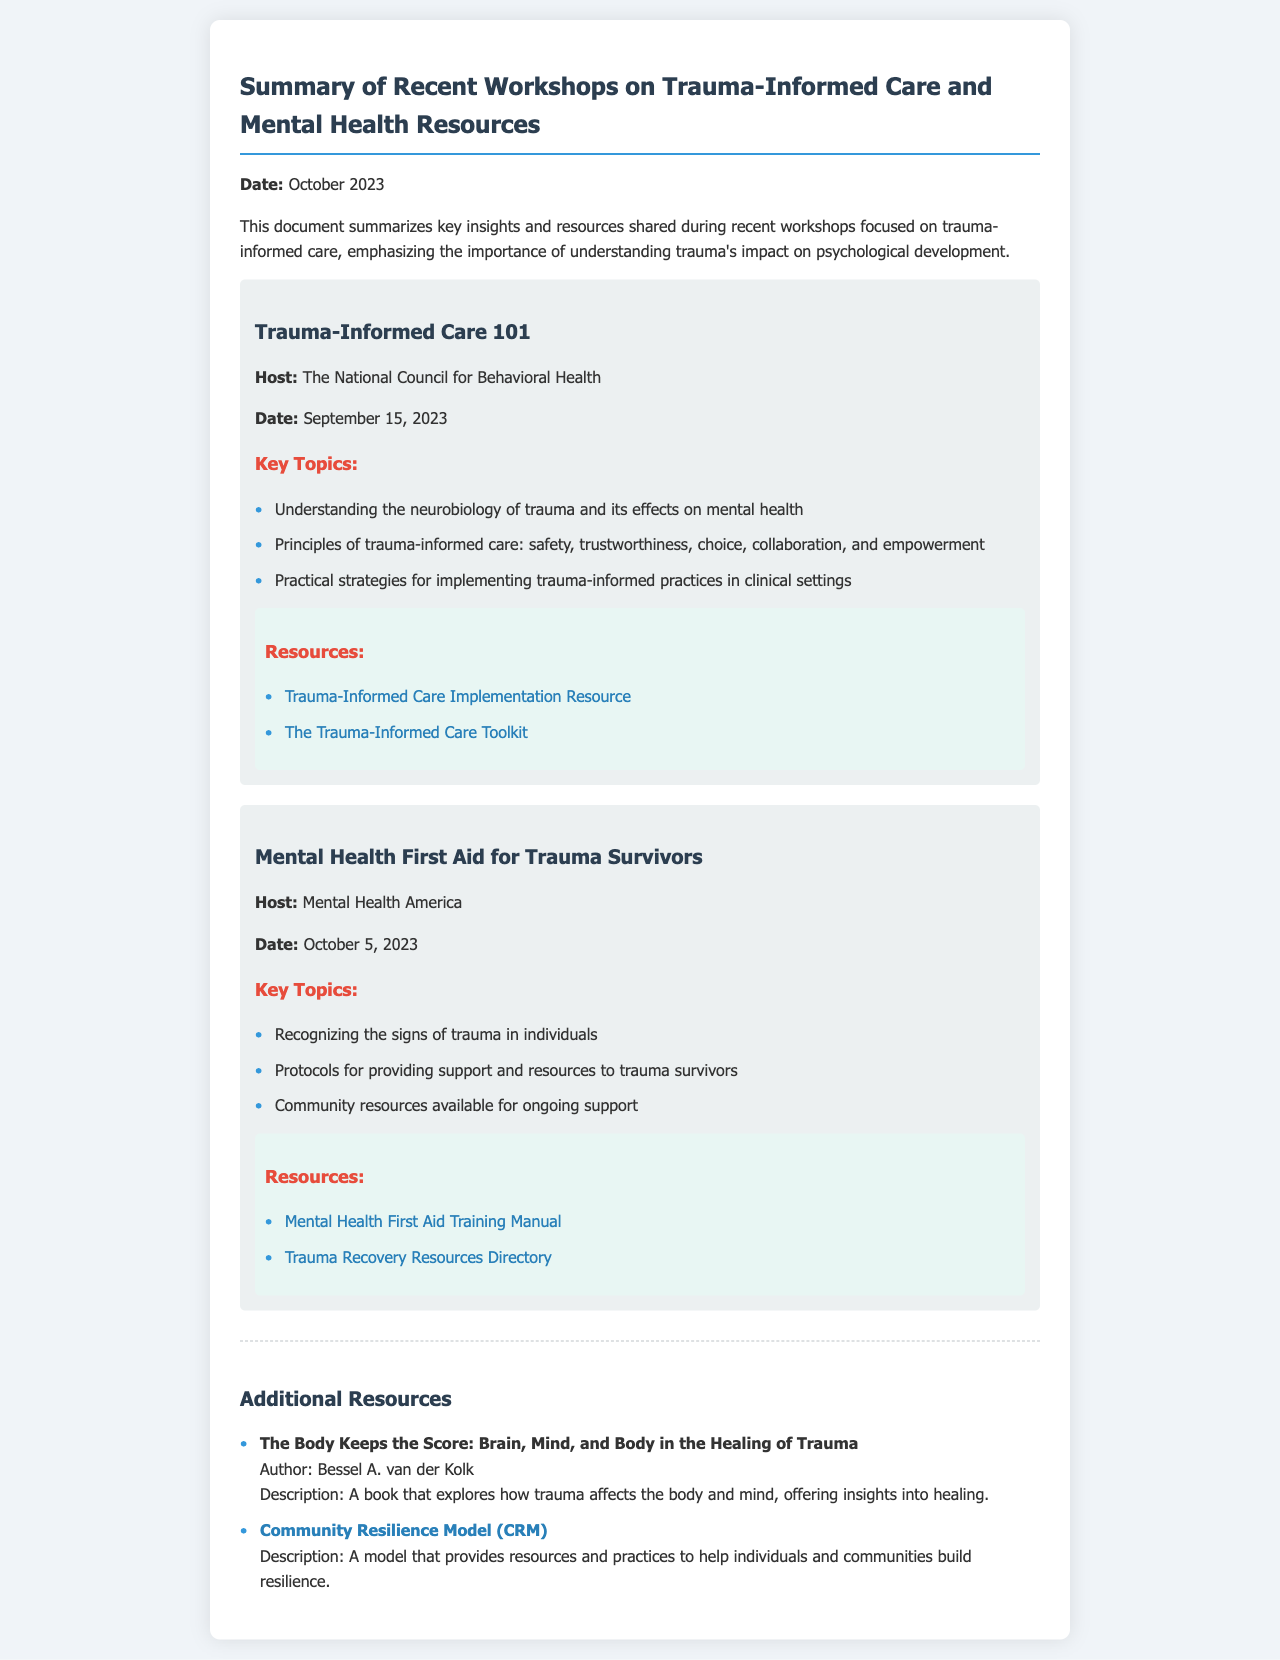What is the date of the document? The document mentions the date in the introductory paragraph as October 2023.
Answer: October 2023 Who hosted the workshop titled "Mental Health First Aid for Trauma Survivors"? The workshop title indicates that it was hosted by Mental Health America.
Answer: Mental Health America What is one key topic of the "Trauma-Informed Care 101" workshop? The document lists several key topics, one of which is understanding the neurobiology of trauma and its effects on mental health.
Answer: Understanding the neurobiology of trauma and its effects on mental health When did the "Trauma-Informed Care 101" workshop take place? The date of the workshop is provided in the workshop section, which states it was held on September 15, 2023.
Answer: September 15, 2023 What resource is associated with the "Mental Health First Aid for Trauma Survivors" workshop? The resources section for this workshop lists the Mental Health First Aid Training Manual as one of the resources.
Answer: Mental Health First Aid Training Manual What book is mentioned as a resource in the additional resources section? The additional resources section mentions "The Body Keeps the Score: Brain, Mind, and Body in the Healing of Trauma" by Bessel A. van der Kolk.
Answer: The Body Keeps the Score: Brain, Mind, and Body in the Healing of Trauma What principle of trauma-informed care is emphasized in the workshops? The document outlines several principles, including safety, trustworthiness, choice, collaboration, and empowerment.
Answer: Safety, trustworthiness, choice, collaboration, and empowerment How many workshops are summarized in the document? The content includes two distinct workshops, each with its own section, indicating there are two workshops summarized.
Answer: Two 